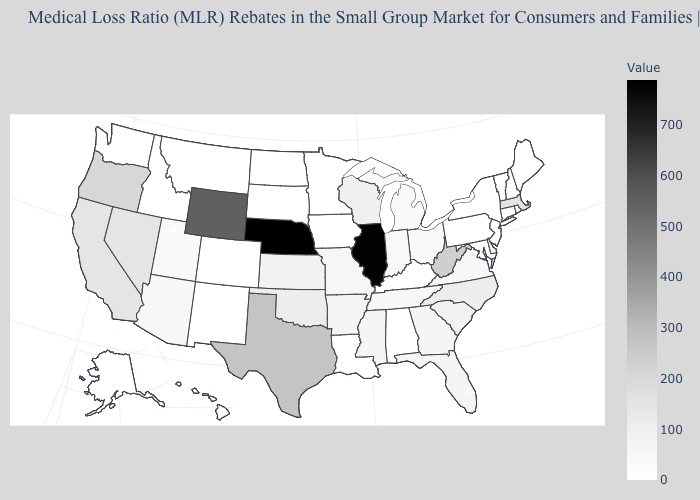Among the states that border Pennsylvania , which have the highest value?
Keep it brief. West Virginia. Does Wyoming have a lower value than Nebraska?
Be succinct. Yes. Does South Carolina have the highest value in the USA?
Be succinct. No. Which states have the lowest value in the South?
Give a very brief answer. Alabama, Kentucky, Louisiana. Is the legend a continuous bar?
Write a very short answer. Yes. Does Minnesota have the lowest value in the MidWest?
Be succinct. Yes. 